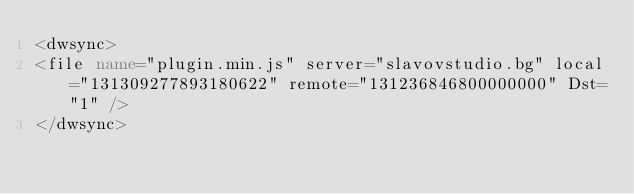Convert code to text. <code><loc_0><loc_0><loc_500><loc_500><_XML_><dwsync>
<file name="plugin.min.js" server="slavovstudio.bg" local="131309277893180622" remote="131236846800000000" Dst="1" />
</dwsync></code> 